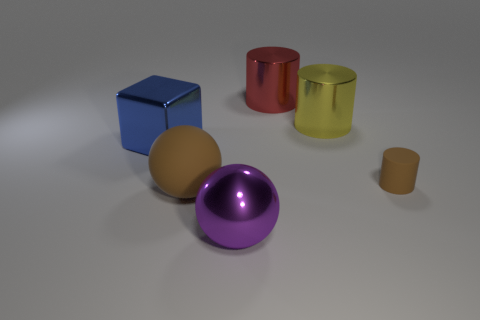In terms of lighting and shadows, what does the image reveal about the position of the light source? The image indicates that the light source is positioned slightly to the top left, as discerned by the direction of the shadows cast by the objects. Each object throws a shadow to the bottom right, suggesting that the light is illuminating the scene from the opposite side. The shadows are soft and diffused, hinting at a light source that is not overly harsh or direct, which contributes to the gentle, even lighting across all the objects. 